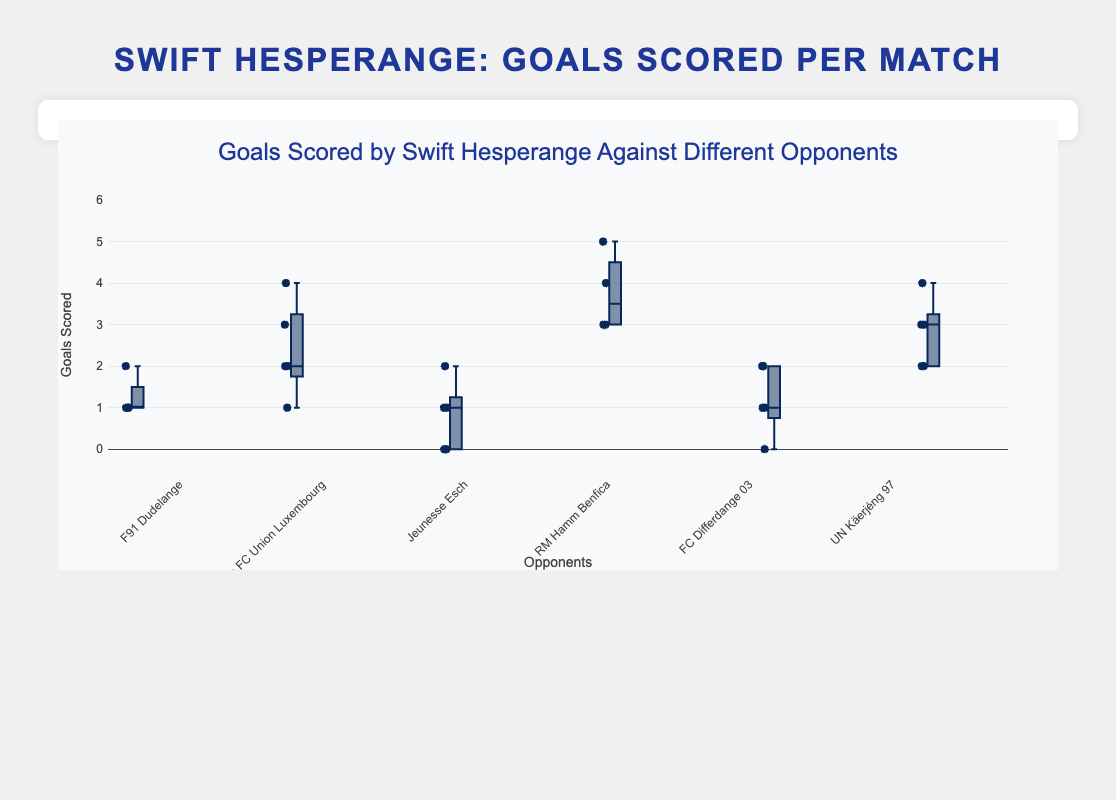What is the title of the figure? The title of the figure is displayed at the top and provides an overview of what the chart is depicting.
Answer: Goals Scored by Swift Hesperange Against Different Opponents How many matches are displayed in the box plot? Each box plot corresponds to a match against a different opponent. Count the number of box plots to determine the number of matches.
Answer: 6 Which opponent has the highest maximum number of goals scored in a single match? The box plot with the highest whisker (top line) represents the opponent against whom the highest number of goals was scored in a single match. Look for the highest whisker.
Answer: RM Hamm Benfica What is the median number of goals scored against FC Differdange 03? Locate the box plot for FC Differdange 03. The line inside the box represents the median value. Identify the value of this line.
Answer: 1 Which opponent had the most consistent number of goals scored against them (least variability)? Consistency can be identified by the smallest interquartile range (IQR). Look for the box plot with the highest whisker near to the lowest whisker.
Answer: F91 Dudelange Which opponent had an outlier in the data, and what was that outlier value? Outliers are points that lie outside the whiskers. Identify the box plot with a point outside of the whiskers and note its value.
Answer: Racing FC Union Luxembourg, outlier value is 4 What is the range of goals scored against Jeunesse Esch (difference between maximum and minimum)? The range can be found by subtracting the minimum value (bottom whisker) from the maximum value (top whisker) for Jeunesse Esch's box plot.
Answer: 2 On average, do Swift Hesperange score more goals against RM Hamm Benfica or UN Käerjéng 97? Compare the median lines (inside the boxes) of the box plots for RM Hamm Benfica and UN Käerjéng 97. The higher median indicates higher average goals.
Answer: UN Käerjéng 97 Against which opponent did Swift Hesperange score an equal number of goals in all but one match? Look for a box plot where most points lie on the same value with one outlier.
Answer: F91 Dudelange Which team has the widest interquartile range (IQR) of goals scored against them? The IQR is represented by the length of the box in the plot. The wider the box, the greater the IQR.
Answer: Racing FC Union Luxembourg 